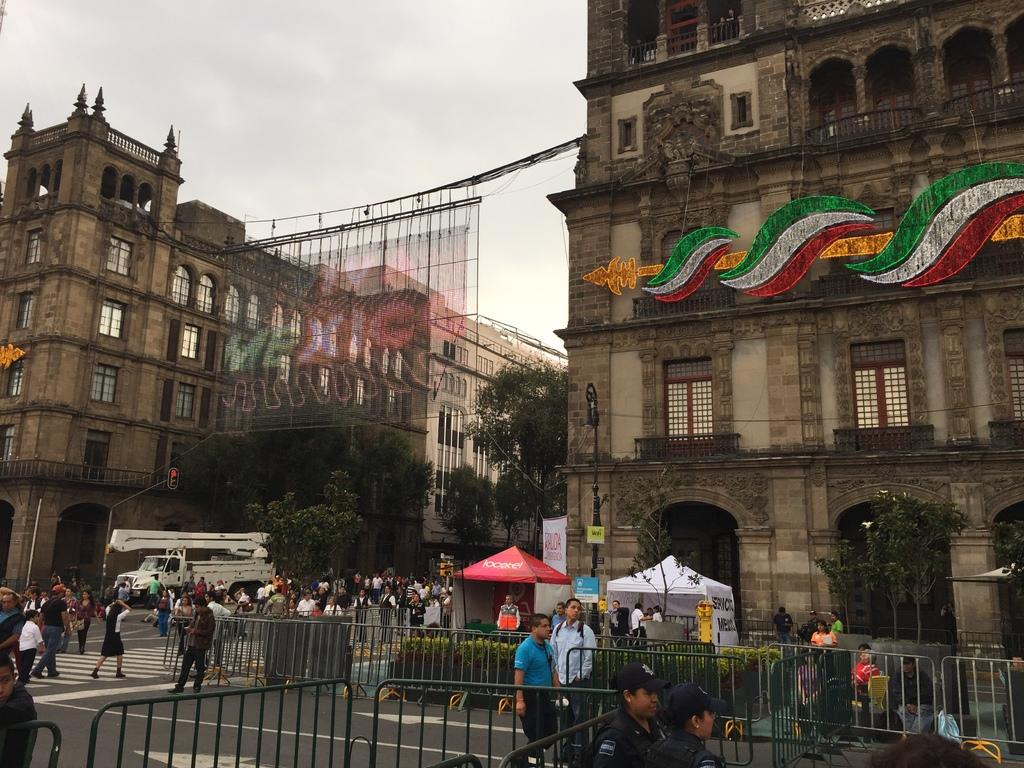How many people can be seen in the image? There are people in the image, but the exact number is not specified. What can be seen near the people in the image? There are railings in the image. What type of vegetation is present in the image? There are plants in the image. What is the primary mode of transportation in the image? There is a vehicle in the image. What type of temporary shelter is present in the image? There are tents in the image. What type of pathway is visible in the image? There is a road in the image. What type of vertical structures are present in the image? There are poles in the image. What type of natural features are present in the image? There are trees in the image. What type of flat, rigid surfaces are present in the image? There are boards in the image. What other objects can be seen in the image? There are other objects in the image, but their specific nature is not specified. What type of structures can be seen in the background of the image? There are buildings in the background of the image. What part of the natural environment is visible in the background of the image? There is sky visible in the background of the image. Where is the prison located in the image? There is no prison present in the image. What type of container for arrows can be seen in the image? There is no quiver present in the image. 